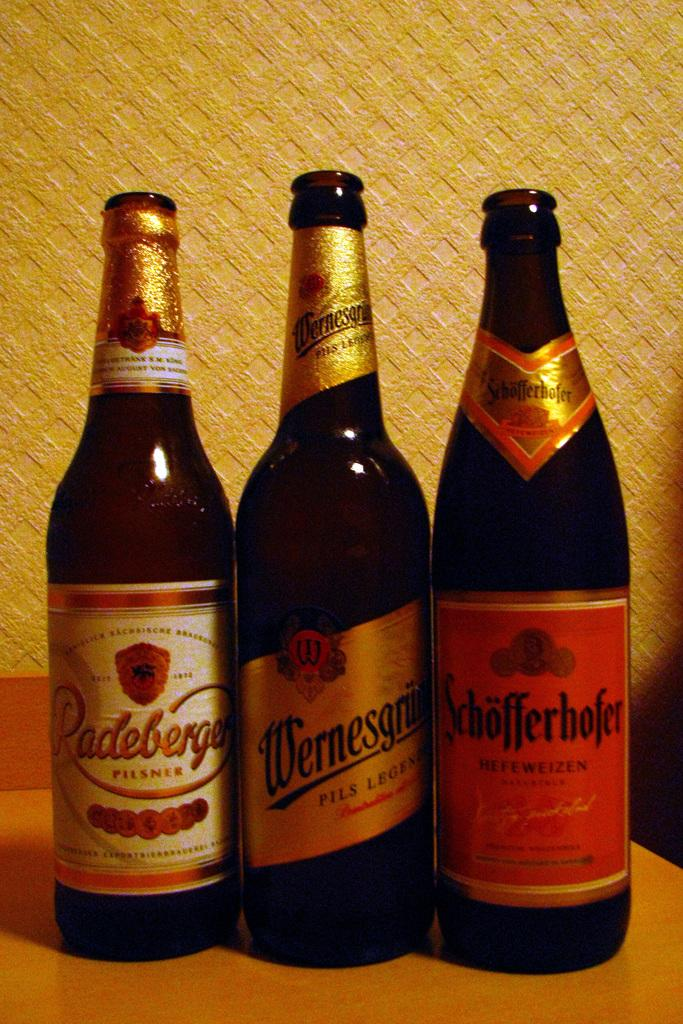How many bottles are visible in the image? There are three bottles in the image. Can you describe the appearance of the bottles? Each bottle has a different label. What type of minister is present in the image? There is no minister present in the image; it only features three bottles with different labels. 